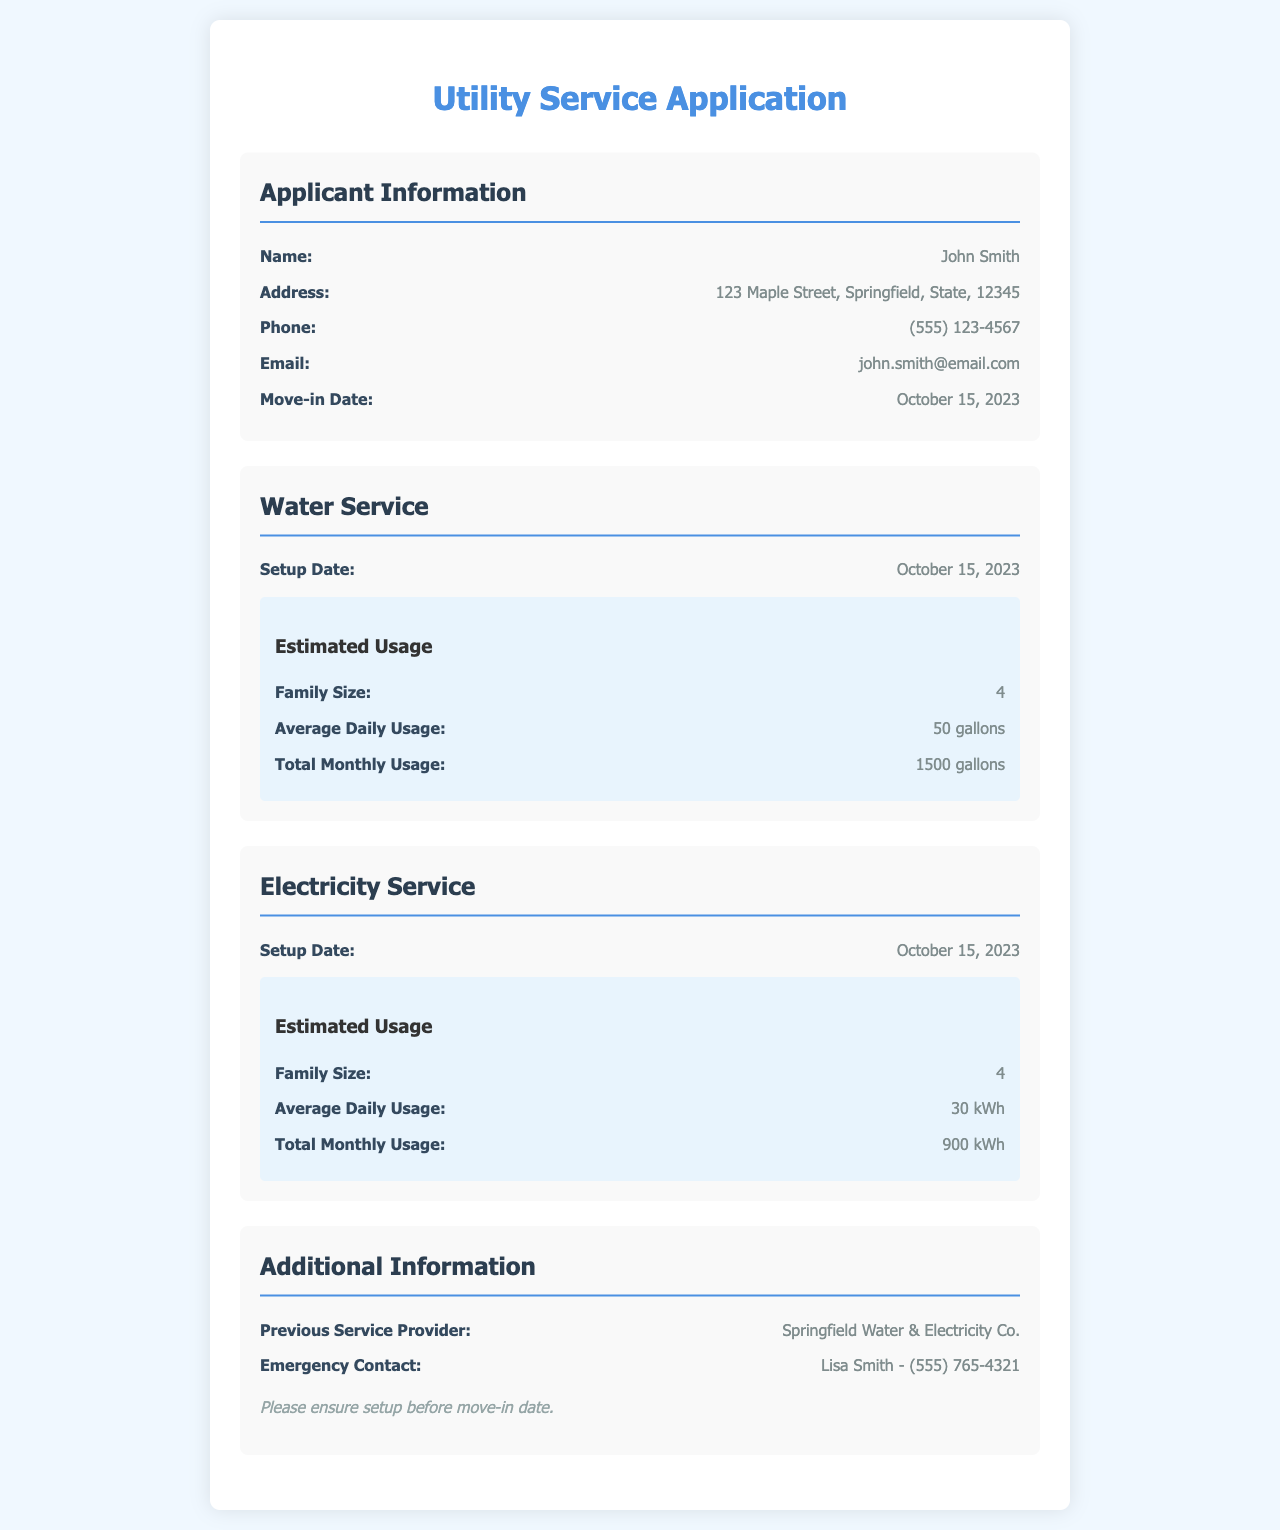What is the name of the applicant? The name of the applicant is provided in the document, listed as John Smith.
Answer: John Smith What is the address of the applicant? The address is detailed in the document, and it is 123 Maple Street, Springfield, State, 12345.
Answer: 123 Maple Street, Springfield, State, 12345 What is the move-in date? The move-in date is explicitly stated in the document as October 15, 2023.
Answer: October 15, 2023 How much is the family's average daily water usage? The document specifies the average daily water usage, which is 50 gallons.
Answer: 50 gallons What is the total monthly electricity usage? The total monthly electricity usage is clearly indicated in the document as 900 kWh.
Answer: 900 kWh What is the emergency contact's name? The emergency contact's name is listed in the additional information section as Lisa Smith.
Answer: Lisa Smith What is the average daily electricity usage for the family? The average daily electricity usage is found in the document, which is stated as 30 kWh.
Answer: 30 kWh When is the setup date for both services? The setup date is noted in both the water and electricity service sections, which is October 15, 2023.
Answer: October 15, 2023 What previous service provider is mentioned in the form? The document specifies the previous service provider as Springfield Water & Electricity Co.
Answer: Springfield Water & Electricity Co 